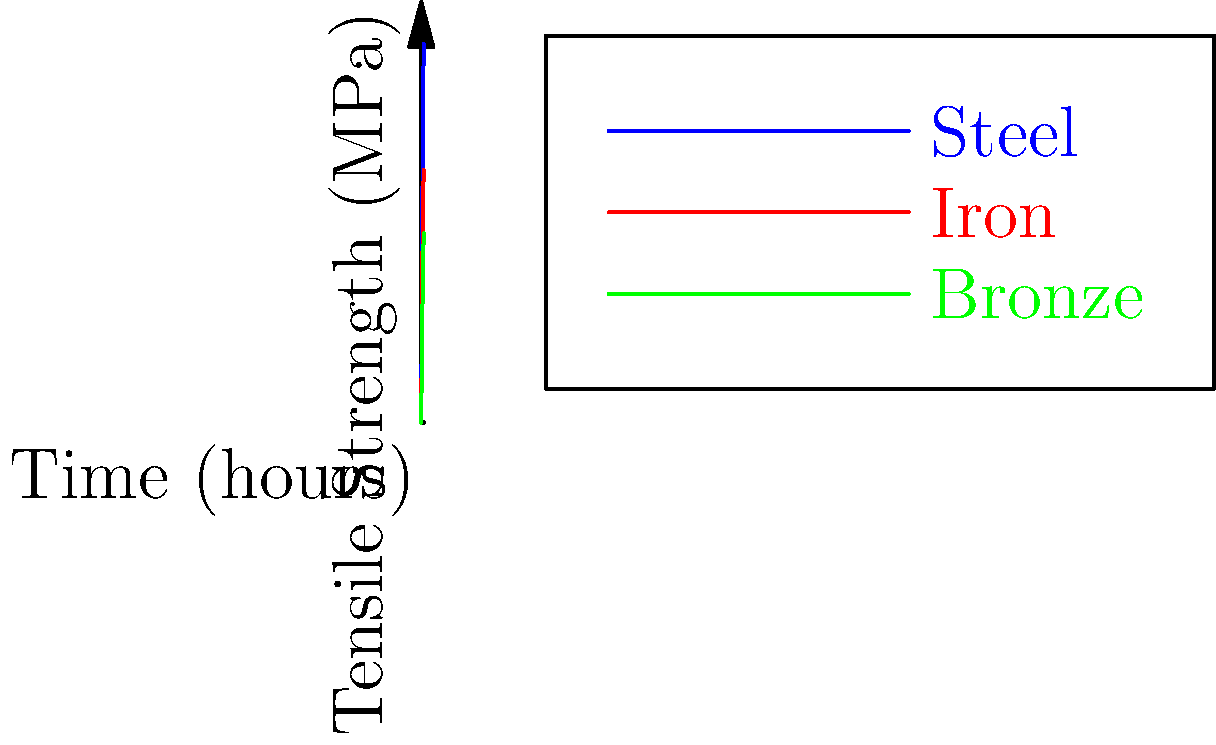The graph shows the tensile strength of three metals commonly used in medieval armor construction as they are heated over time. As an amateur medieval reenactor with an engineering background, you're tasked with selecting the best metal for a breastplate that can withstand high impact. After 2 hours of heating, what is the difference in tensile strength between steel and bronze, and how might this influence your choice of metal? To solve this problem, we'll follow these steps:

1. Identify the relevant data points:
   - We need to look at the 2-hour mark on the x-axis.
   - Find the corresponding y-values (tensile strength) for steel and bronze.

2. Read the tensile strength values:
   - Steel (blue line) at 2 hours: 350 MPa
   - Bronze (green line) at 2 hours: 175 MPa

3. Calculate the difference:
   $$ \text{Difference} = \text{Steel strength} - \text{Bronze strength} $$
   $$ = 350 \text{ MPa} - 175 \text{ MPa} = 175 \text{ MPa} $$

4. Interpret the results:
   - Steel has a significantly higher tensile strength than bronze after 2 hours of heating.
   - The difference of 175 MPa represents a 100% increase in strength for steel over bronze.

5. Consider the implications for armor construction:
   - Higher tensile strength generally means better resistance to impacts and deformation.
   - Steel would be able to withstand much higher forces before failing compared to bronze.
   - This makes steel a superior choice for a breastplate that needs to withstand high impact.

6. Factor in your engineering background:
   - As a retired aerospace engineer, you understand the importance of material properties in design.
   - The significant strength advantage of steel would likely outweigh other factors like weight or cost in this application.
Answer: 175 MPa; steel is significantly stronger and better suited for high-impact resistance in armor. 